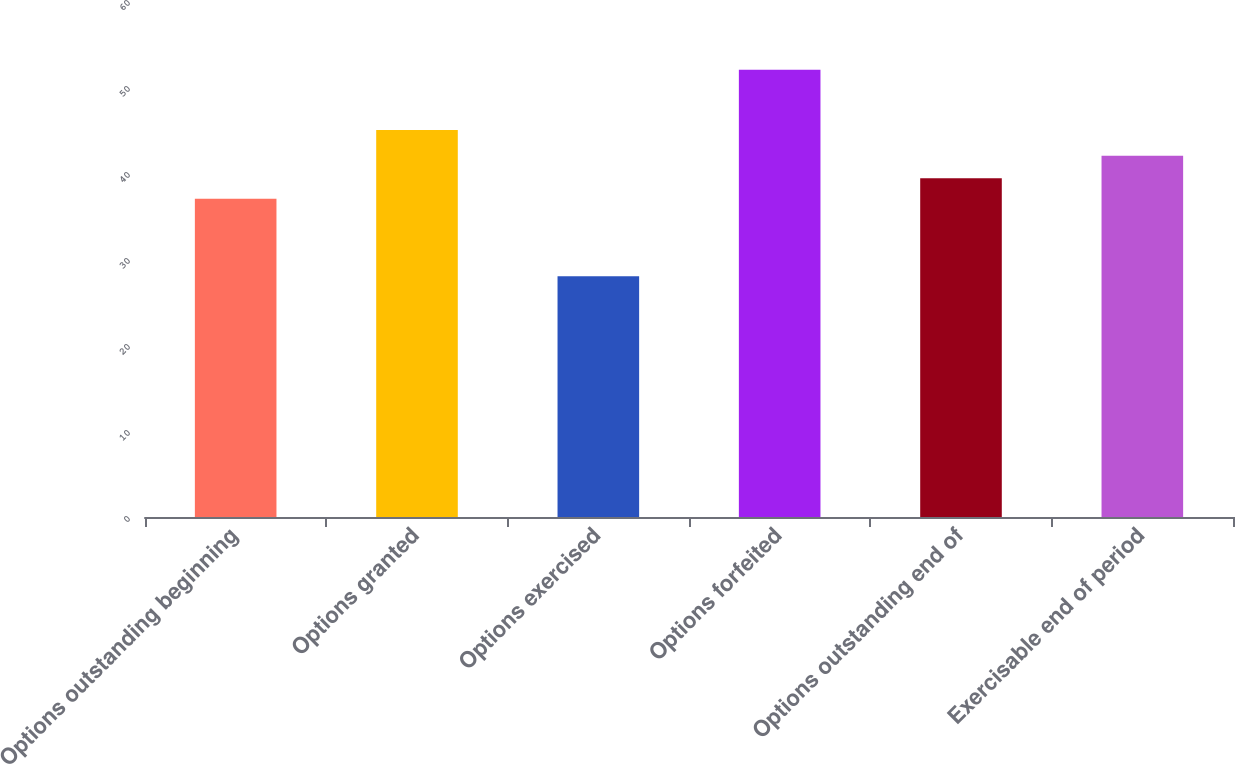<chart> <loc_0><loc_0><loc_500><loc_500><bar_chart><fcel>Options outstanding beginning<fcel>Options granted<fcel>Options exercised<fcel>Options forfeited<fcel>Options outstanding end of<fcel>Exercisable end of period<nl><fcel>37<fcel>45<fcel>28<fcel>52<fcel>39.4<fcel>42<nl></chart> 